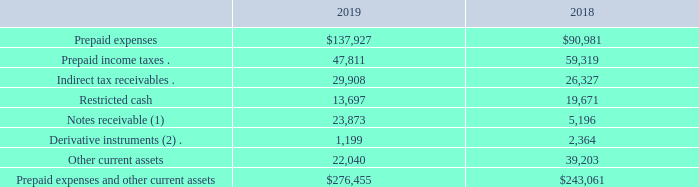Prepaid expenses and other current assets
Prepaid expenses and other current assets consisted of the following at December 31, 2019 and 2018 (in thousands):
(1) In November 2014 and February 2016, we entered into a term loan agreement and a convertible loan agreement, respectively, with Clean Energy Collective, LLC (“CEC”). Our term loan bears interest at 16% per annum, and our convertible loan bears interest at 10% per annum. In November 2018, we amended the terms of the loan agreements to (i) extend their maturity to June 2020, (ii) waive the conversion features on our convertible loan, and (iii) increase the frequency of interest payments, subject to certain conditions. In January 2019, CEC finalized certain restructuring arrangements, which resulted in a dilution of our ownership interest in CEC and the loss of our representation on the company’s board of managers. As a result of such restructuring, CEC no longer qualified to be accounted for under the equity method. As of December 31, 2019, the aggregate balance outstanding on the loans was $23.9 million and was presented within “Prepaid expenses and other current assets.” As of December 31, 2018, the aggregate balance outstanding on the loans was $22.8 million and was presented within “Notes receivable, affiliate.”
(2) See Note 9. “Derivative Financial Instruments” to our consolidated financial statements for discussion of our derivative instruments.
What is the interest rate of the term loan? Our term loan bears interest at 16% per annum. What amendment was made to the convertible loan agreement in 2018? Waive the conversion features on our convertible loan. Why is CEC no longer qualified to be accounted under the equity method in 2019? Cec finalized certain restructuring arrangements, which resulted in a dilution of our ownership interest in cec and the loss of our representation on the company’s board of managers. How much was the increase in prepaid expenses from 2018 to 2019?
Answer scale should be: thousand. 137,927-90,981 
Answer: 46946. What is the difference between notes receivables from 2018 to 2019?
Answer scale should be: thousand. 23,873 - 5,196 
Answer: 18677. What is the percentage increase in total prepaid expenses and other current assets from 2018 to 2019?
Answer scale should be: percent. (276,455- 243,061)/243,061 
Answer: 13.74. 